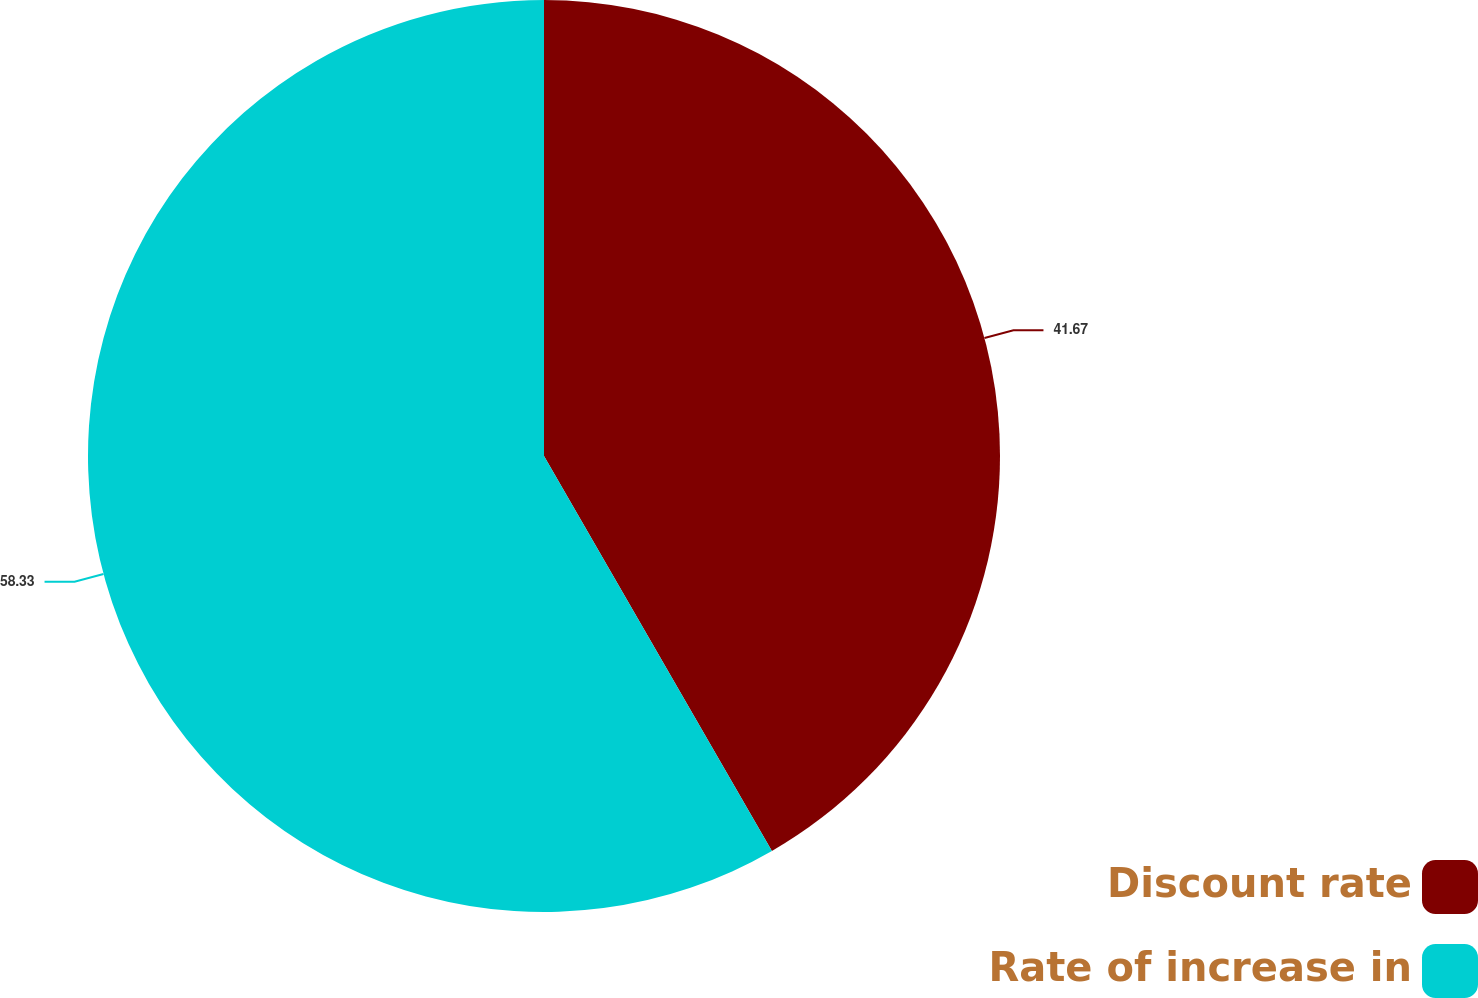Convert chart. <chart><loc_0><loc_0><loc_500><loc_500><pie_chart><fcel>Discount rate<fcel>Rate of increase in<nl><fcel>41.67%<fcel>58.33%<nl></chart> 